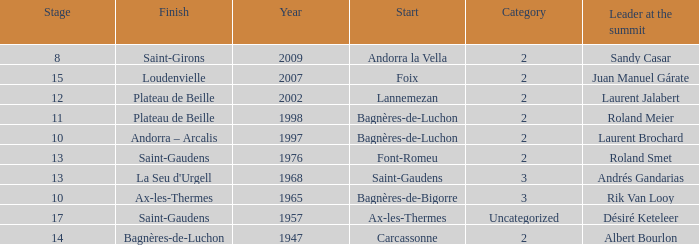Name the start of an event in Catagory 2 of the year 1947. Carcassonne. 